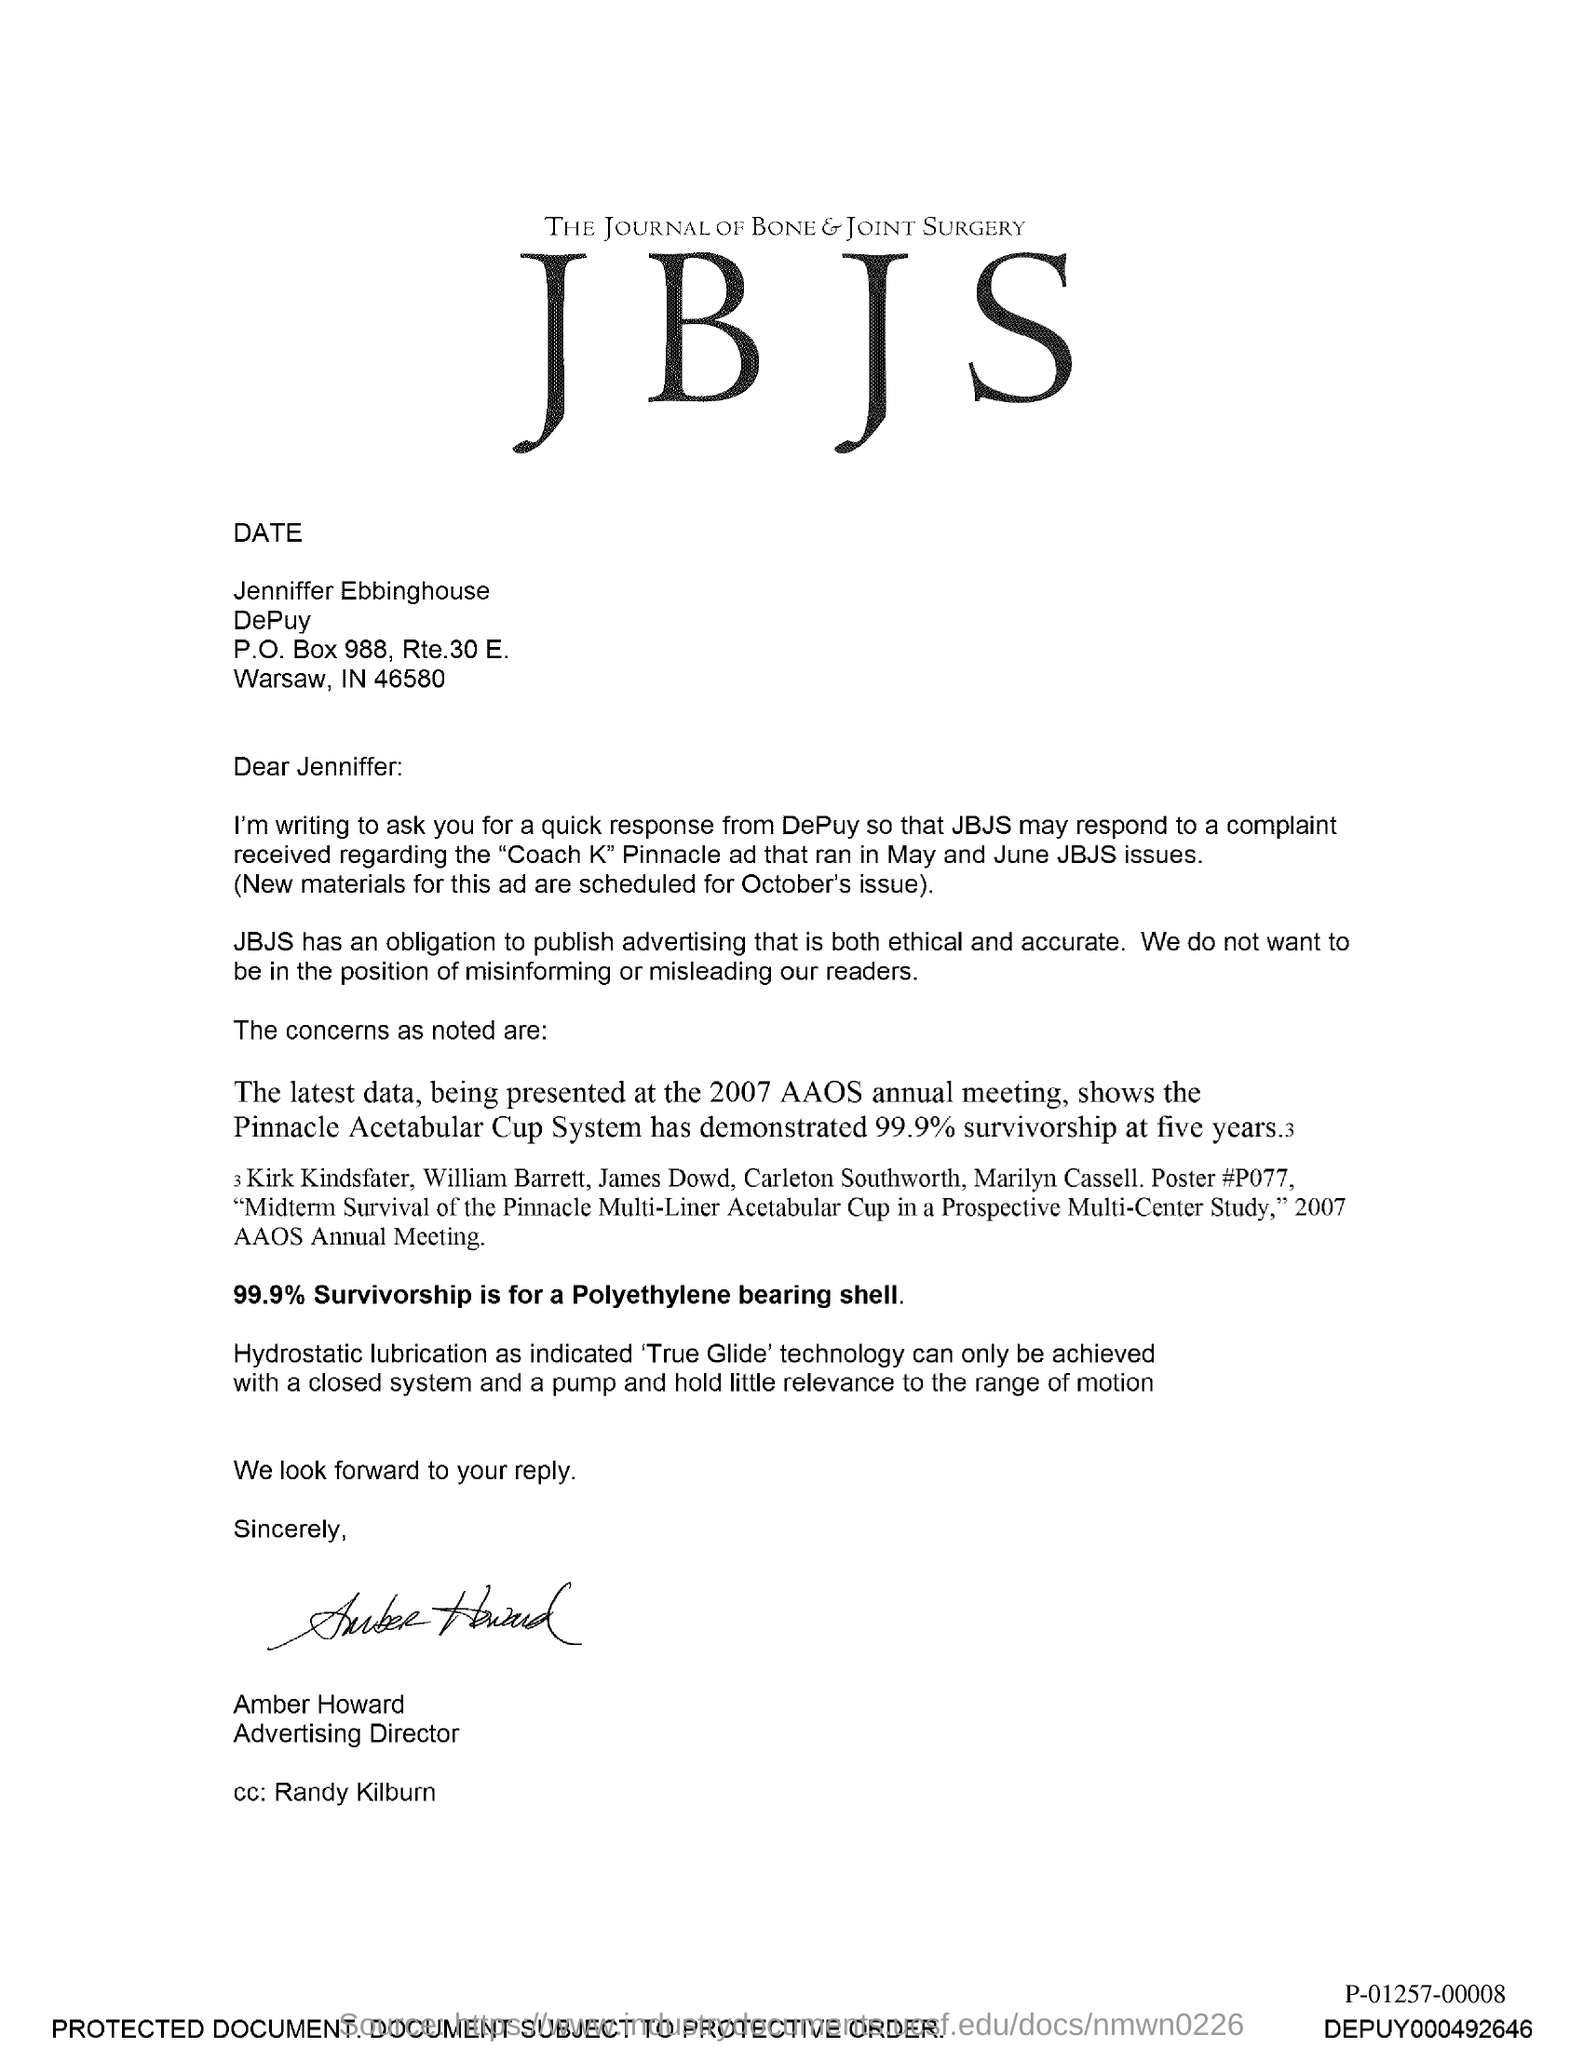Which Journal is mentioned in the letterhead?
Give a very brief answer. JBJS. Who is the addressee of this letter?
Offer a very short reply. Jennifer:. Who is the sender of this letter?
Give a very brief answer. AMBER HOWARD. What is the designation of Amber Howard?
Provide a short and direct response. ADVERTISING DIRECTOR. Who is marked in the cc of this letter?
Ensure brevity in your answer.  Randy Kilburn. What percentage of survivorship is there for a Polyethylene bearing shell?
Your answer should be very brief. 99.9%. Which Journal has an obligation to publish advertising that is both ethical and accurate?
Offer a terse response. JBJS. What is the fullform of JBJS?
Provide a short and direct response. THE JOURNAL OF BONE & JOINT SURGERY. 